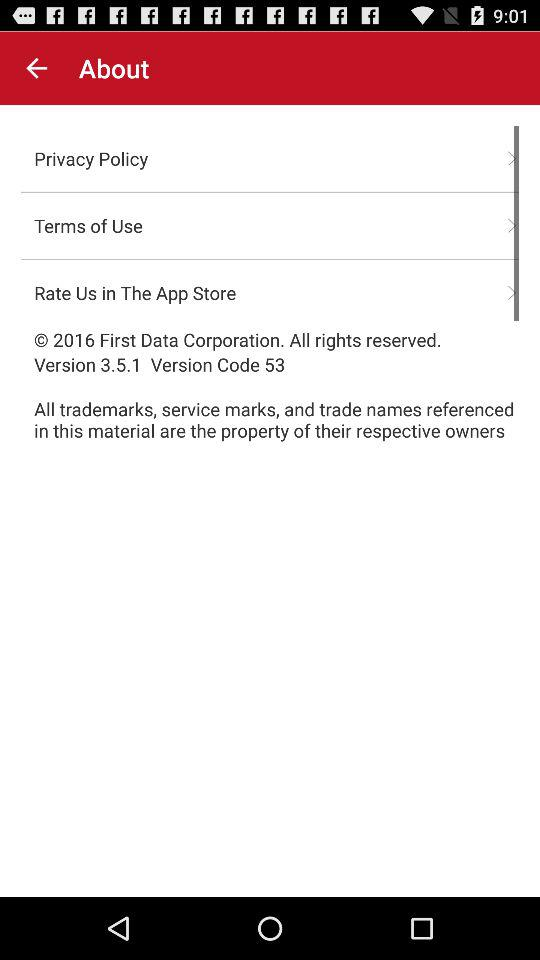What is the version? The version is 3.5.1. 